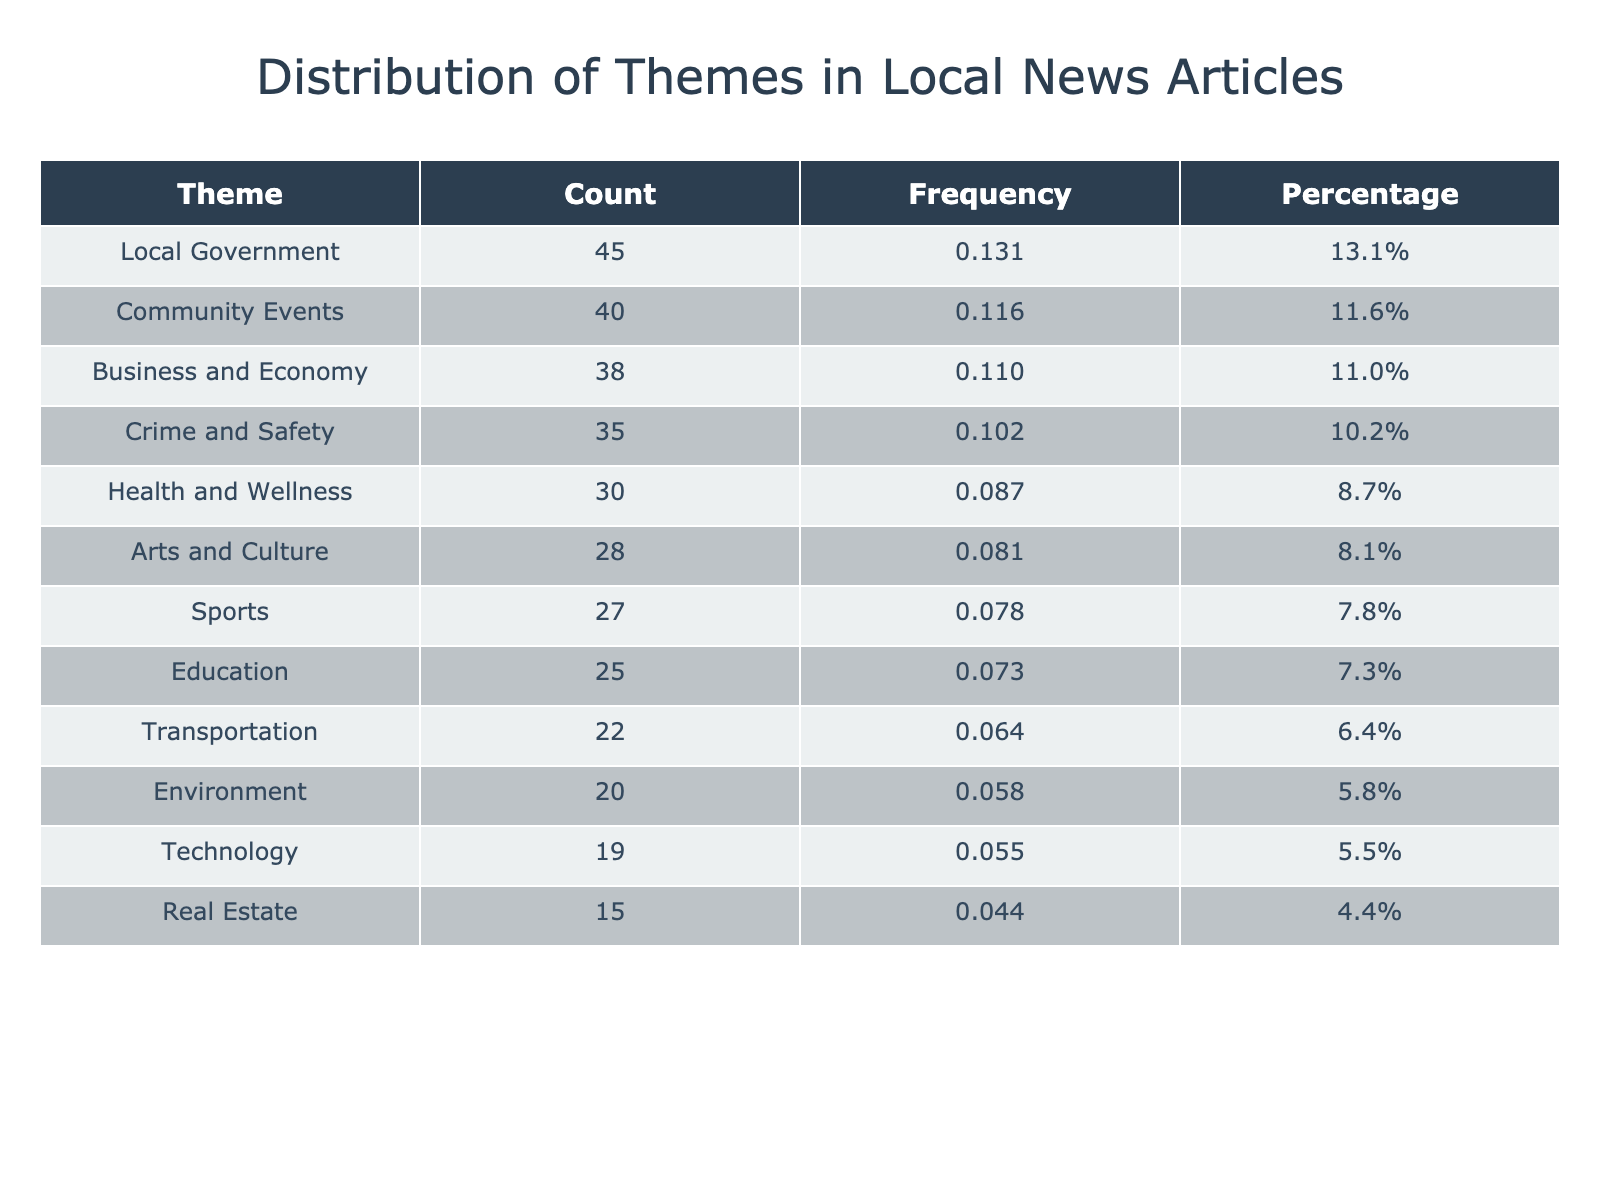What is the count of articles related to Local Government? The count for Local Government is directly listed in the table under the Count column. It shows a value of 45.
Answer: 45 Which theme has the highest count of articles? By examining the Count column, Local Government has the highest value of 45 compared to others.
Answer: Local Government How many articles are there about Community Events and Sports combined? To find this, add the Count for Community Events (40) and Sports (27). 40 + 27 = 67.
Answer: 67 Is the count of articles on Health and Wellness greater than that of Arts and Culture? The count for Health and Wellness is 30, while for Arts and Culture it is 28. Since 30 > 28, the statement is true.
Answer: Yes What is the percentage representation of Crime and Safety articles in the total? The total count of all articles is 45 + 30 + 25 + 40 + 35 + 20 + 38 + 28 + 22 + 27 + 15 + 19 =  359. The count of Crime and Safety is 35. The percentage is (35/359)*100 ≈ 9.7%.
Answer: 9.7% What is the combined count of articles related to Technology and Environment? The count for Technology is 19 and for Environment is 20. Adding these gives 19 + 20 = 39.
Answer: 39 Is there a theme with fewer than 20 articles? Yes, Real Estate has a count of 15, which is fewer than 20.
Answer: Yes Which theme has the lowest frequency percentage? The theme with the lowest count is Real Estate (15 articles), so it will have the lowest frequency percentage as well. The total is 359. The percentage is (15/359)*100 ≈ 4.2%.
Answer: Real Estate 